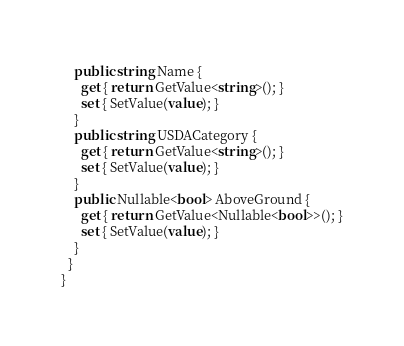Convert code to text. <code><loc_0><loc_0><loc_500><loc_500><_C#_>    public string Name {
      get { return GetValue<string>(); }
      set { SetValue(value); }
    }
    public string USDACategory {
      get { return GetValue<string>(); }
      set { SetValue(value); }
    }
    public Nullable<bool> AboveGround {
      get { return GetValue<Nullable<bool>>(); }
      set { SetValue(value); }
    }
  }
}
</code> 